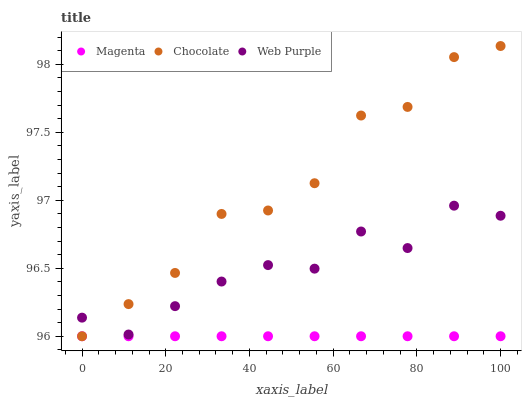Does Magenta have the minimum area under the curve?
Answer yes or no. Yes. Does Chocolate have the maximum area under the curve?
Answer yes or no. Yes. Does Web Purple have the minimum area under the curve?
Answer yes or no. No. Does Web Purple have the maximum area under the curve?
Answer yes or no. No. Is Magenta the smoothest?
Answer yes or no. Yes. Is Chocolate the roughest?
Answer yes or no. Yes. Is Web Purple the smoothest?
Answer yes or no. No. Is Web Purple the roughest?
Answer yes or no. No. Does Magenta have the lowest value?
Answer yes or no. Yes. Does Web Purple have the lowest value?
Answer yes or no. No. Does Chocolate have the highest value?
Answer yes or no. Yes. Does Web Purple have the highest value?
Answer yes or no. No. Is Magenta less than Web Purple?
Answer yes or no. Yes. Is Web Purple greater than Magenta?
Answer yes or no. Yes. Does Web Purple intersect Chocolate?
Answer yes or no. Yes. Is Web Purple less than Chocolate?
Answer yes or no. No. Is Web Purple greater than Chocolate?
Answer yes or no. No. Does Magenta intersect Web Purple?
Answer yes or no. No. 